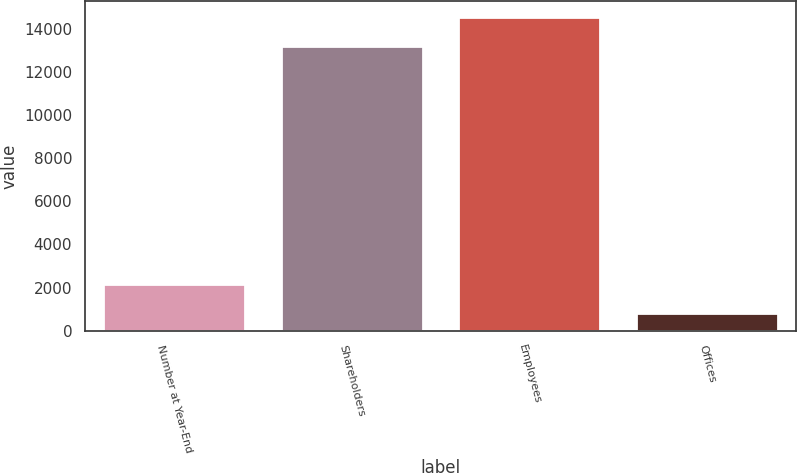Convert chart. <chart><loc_0><loc_0><loc_500><loc_500><bar_chart><fcel>Number at Year-End<fcel>Shareholders<fcel>Employees<fcel>Offices<nl><fcel>2171.4<fcel>13207<fcel>14546.4<fcel>832<nl></chart> 